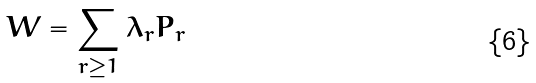Convert formula to latex. <formula><loc_0><loc_0><loc_500><loc_500>W = \sum _ { r \geq 1 } \lambda _ { r } P _ { r }</formula> 